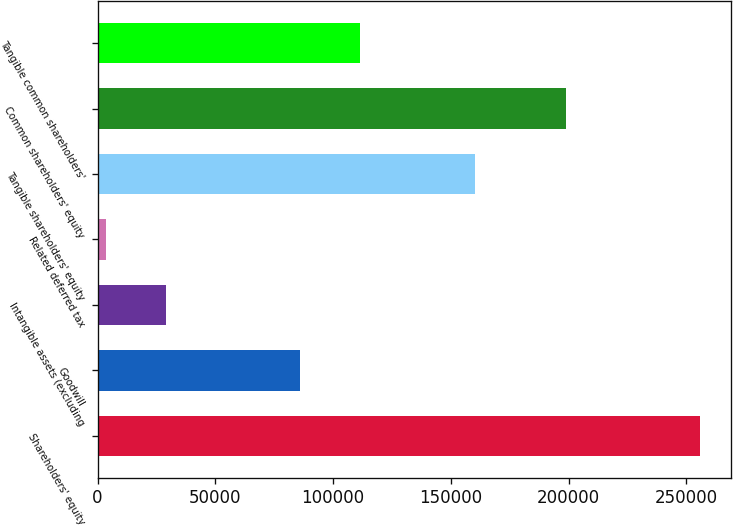Convert chart to OTSL. <chart><loc_0><loc_0><loc_500><loc_500><bar_chart><fcel>Shareholders' equity<fcel>Goodwill<fcel>Intangible assets (excluding<fcel>Related deferred tax<fcel>Tangible shareholders' equity<fcel>Common shareholders' equity<fcel>Tangible common shareholders'<nl><fcel>255983<fcel>86170<fcel>28950.8<fcel>3725<fcel>160315<fcel>198843<fcel>111396<nl></chart> 